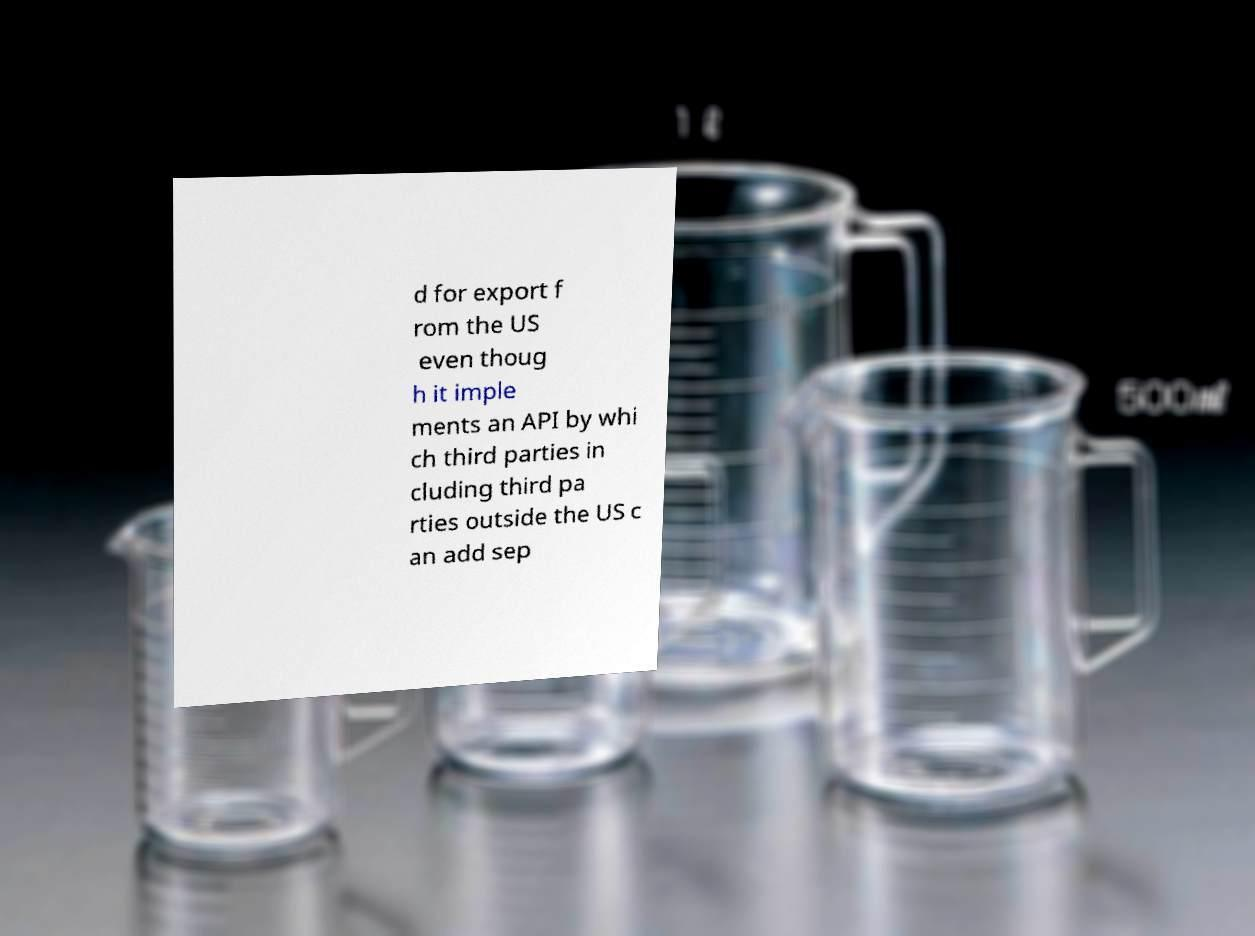Please read and relay the text visible in this image. What does it say? d for export f rom the US even thoug h it imple ments an API by whi ch third parties in cluding third pa rties outside the US c an add sep 